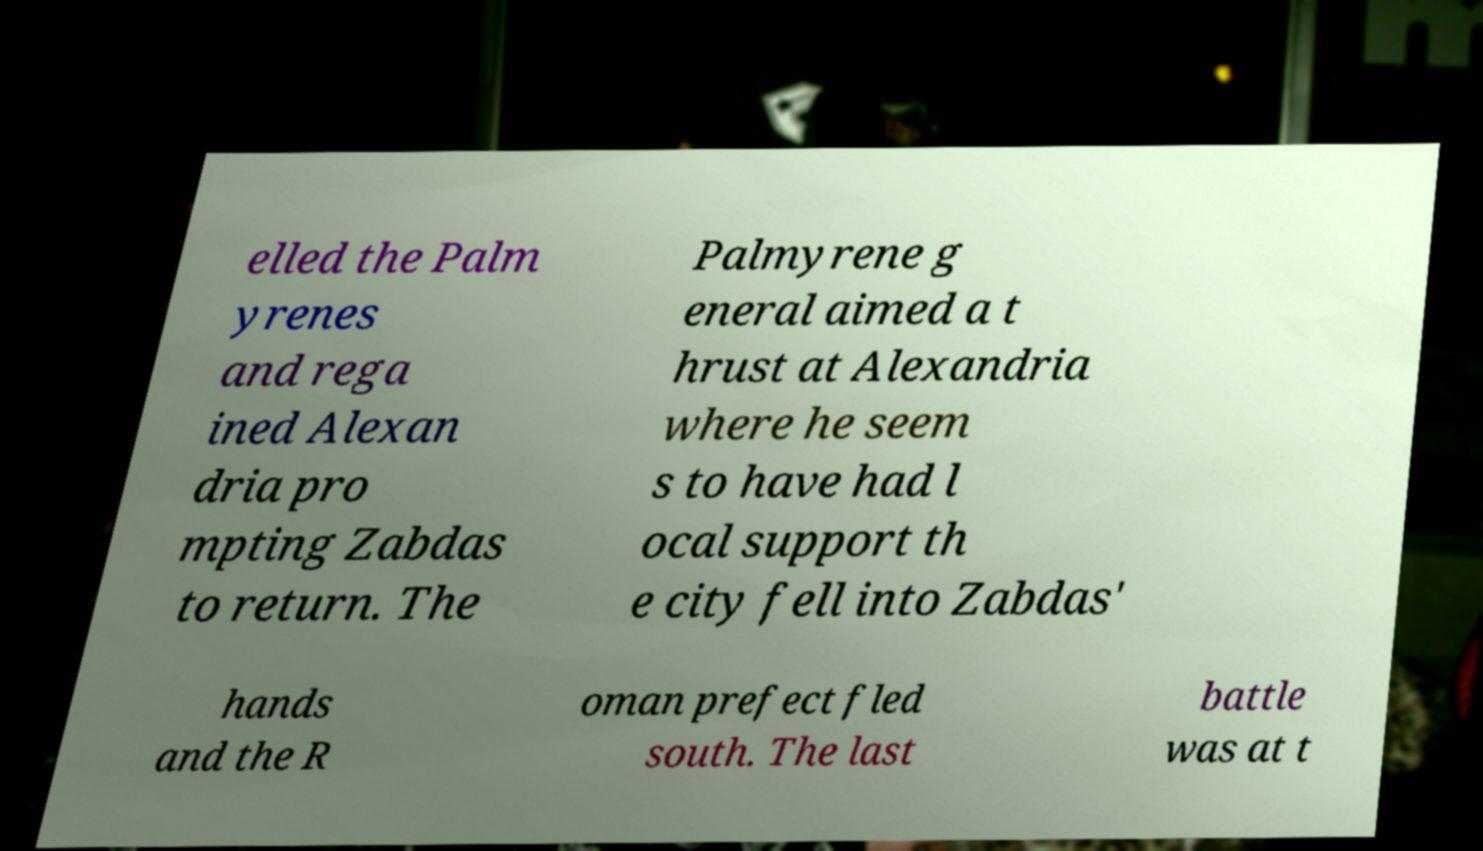Please identify and transcribe the text found in this image. elled the Palm yrenes and rega ined Alexan dria pro mpting Zabdas to return. The Palmyrene g eneral aimed a t hrust at Alexandria where he seem s to have had l ocal support th e city fell into Zabdas' hands and the R oman prefect fled south. The last battle was at t 